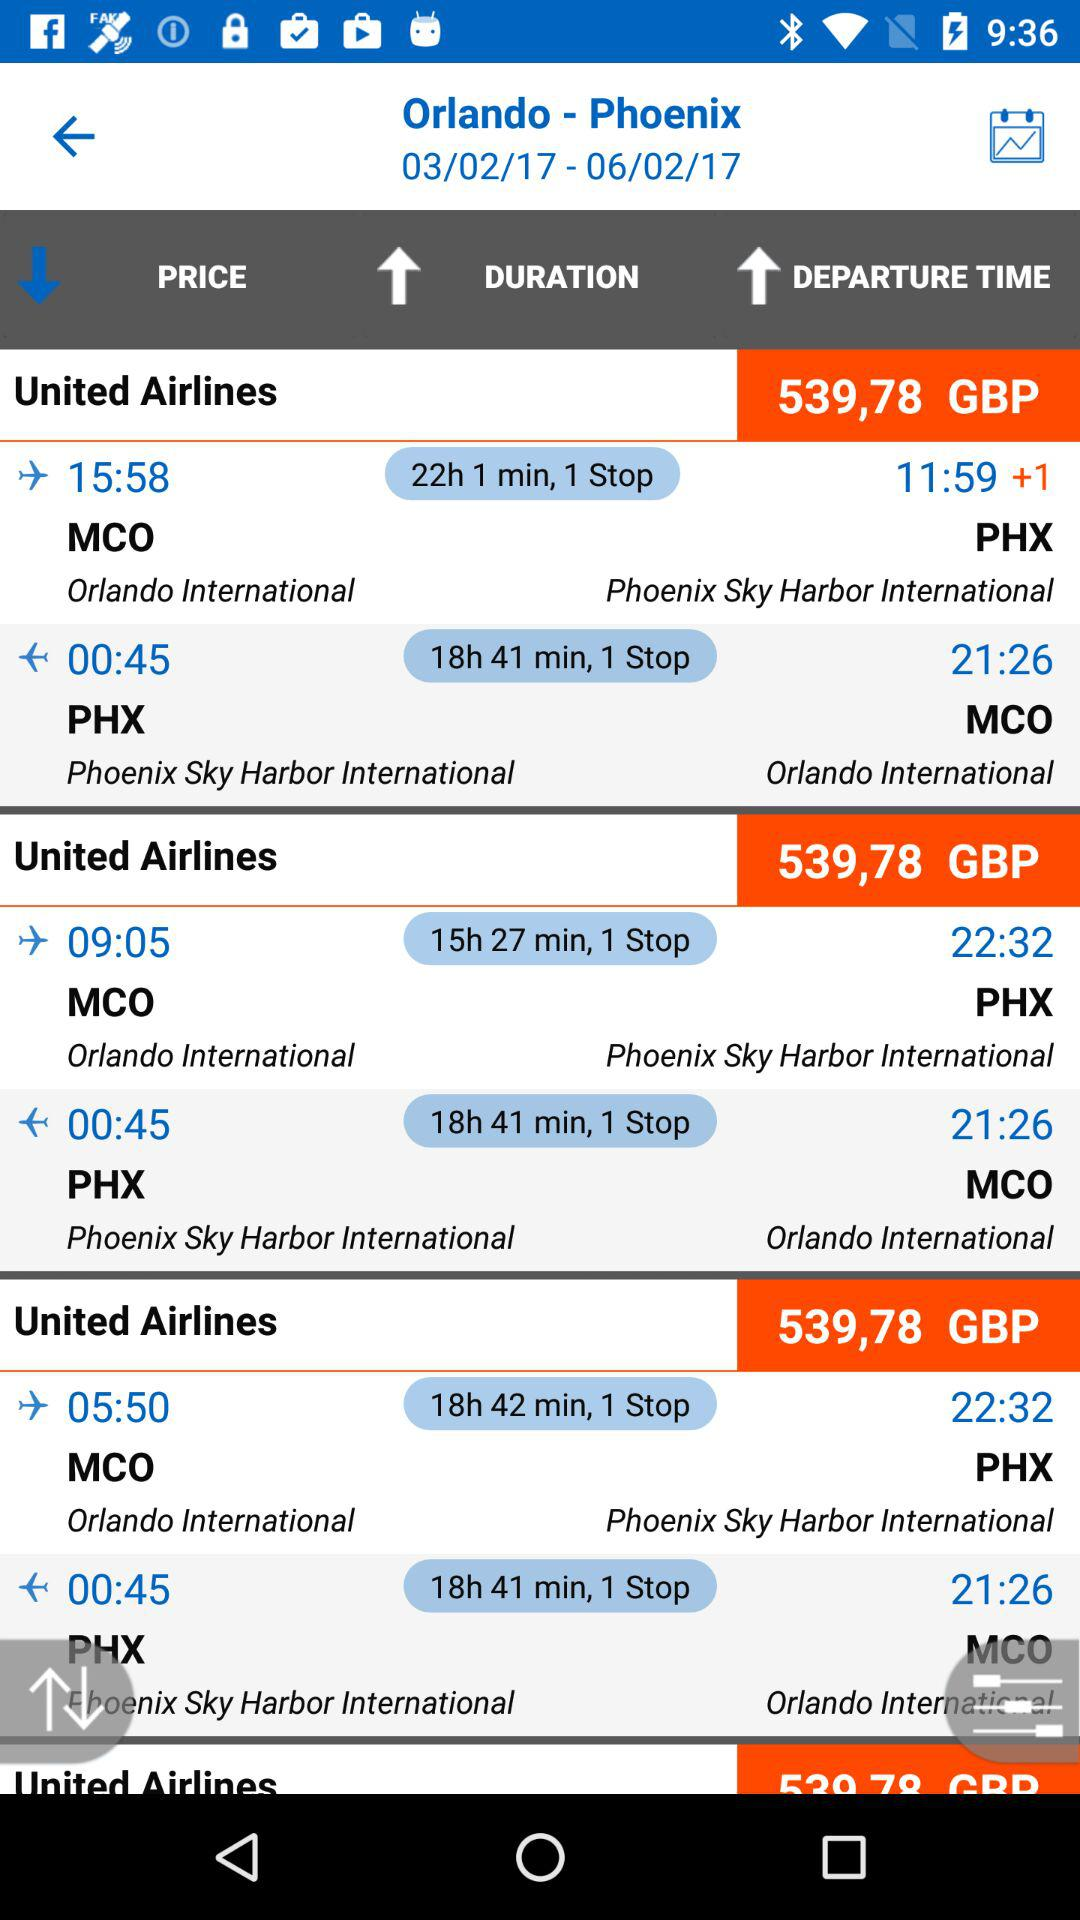Which tab is selected?
When the provided information is insufficient, respond with <no answer>. <no answer> 